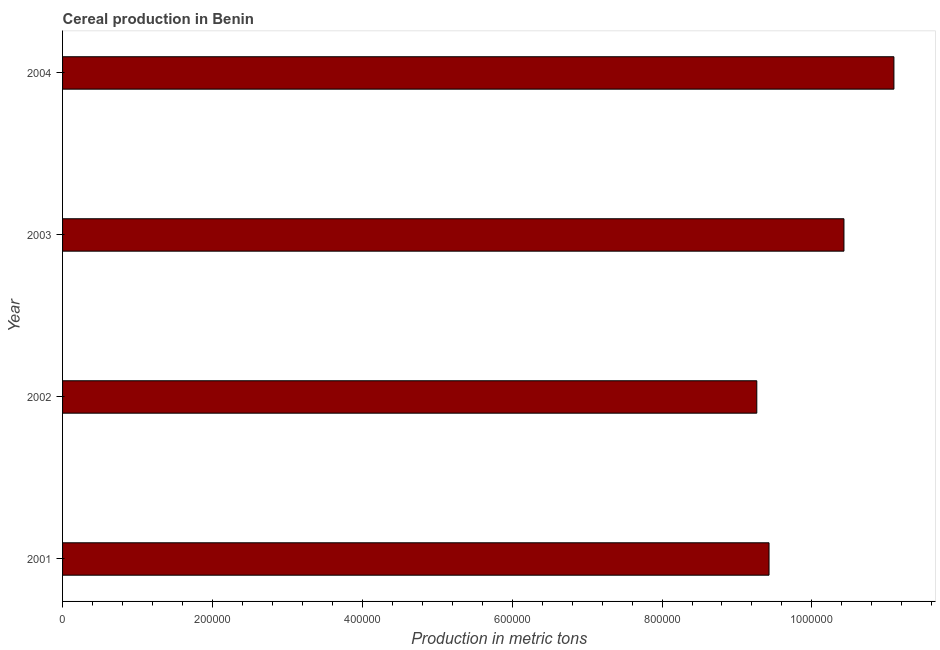What is the title of the graph?
Make the answer very short. Cereal production in Benin. What is the label or title of the X-axis?
Offer a terse response. Production in metric tons. What is the label or title of the Y-axis?
Your answer should be compact. Year. What is the cereal production in 2004?
Give a very brief answer. 1.11e+06. Across all years, what is the maximum cereal production?
Provide a succinct answer. 1.11e+06. Across all years, what is the minimum cereal production?
Your answer should be very brief. 9.26e+05. In which year was the cereal production maximum?
Provide a succinct answer. 2004. What is the sum of the cereal production?
Provide a succinct answer. 4.02e+06. What is the difference between the cereal production in 2003 and 2004?
Your answer should be very brief. -6.67e+04. What is the average cereal production per year?
Ensure brevity in your answer.  1.01e+06. What is the median cereal production?
Offer a very short reply. 9.93e+05. Is the cereal production in 2002 less than that in 2004?
Your answer should be very brief. Yes. What is the difference between the highest and the second highest cereal production?
Ensure brevity in your answer.  6.67e+04. What is the difference between the highest and the lowest cereal production?
Keep it short and to the point. 1.83e+05. In how many years, is the cereal production greater than the average cereal production taken over all years?
Ensure brevity in your answer.  2. Are all the bars in the graph horizontal?
Give a very brief answer. Yes. How many years are there in the graph?
Provide a succinct answer. 4. What is the Production in metric tons of 2001?
Keep it short and to the point. 9.43e+05. What is the Production in metric tons in 2002?
Make the answer very short. 9.26e+05. What is the Production in metric tons of 2003?
Your response must be concise. 1.04e+06. What is the Production in metric tons in 2004?
Keep it short and to the point. 1.11e+06. What is the difference between the Production in metric tons in 2001 and 2002?
Offer a terse response. 1.63e+04. What is the difference between the Production in metric tons in 2001 and 2003?
Your response must be concise. -1.00e+05. What is the difference between the Production in metric tons in 2001 and 2004?
Offer a terse response. -1.67e+05. What is the difference between the Production in metric tons in 2002 and 2003?
Your answer should be very brief. -1.16e+05. What is the difference between the Production in metric tons in 2002 and 2004?
Give a very brief answer. -1.83e+05. What is the difference between the Production in metric tons in 2003 and 2004?
Ensure brevity in your answer.  -6.67e+04. What is the ratio of the Production in metric tons in 2001 to that in 2002?
Offer a very short reply. 1.02. What is the ratio of the Production in metric tons in 2001 to that in 2003?
Your response must be concise. 0.9. What is the ratio of the Production in metric tons in 2001 to that in 2004?
Offer a terse response. 0.85. What is the ratio of the Production in metric tons in 2002 to that in 2003?
Provide a short and direct response. 0.89. What is the ratio of the Production in metric tons in 2002 to that in 2004?
Your response must be concise. 0.83. What is the ratio of the Production in metric tons in 2003 to that in 2004?
Give a very brief answer. 0.94. 